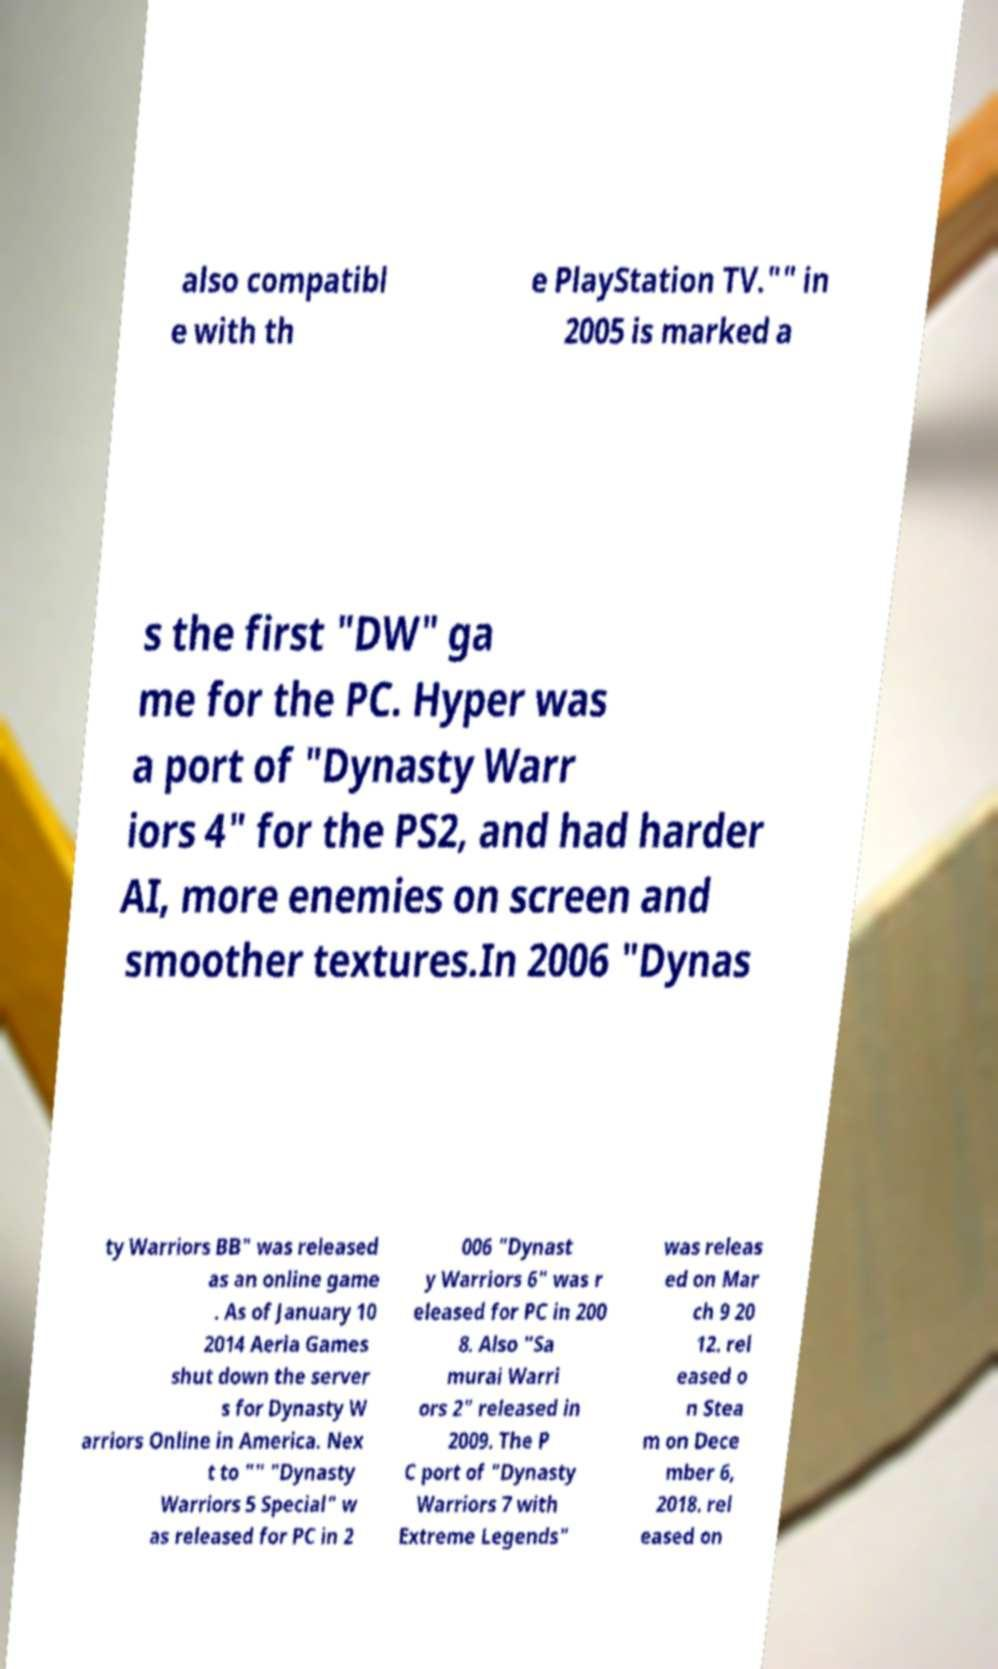Could you extract and type out the text from this image? also compatibl e with th e PlayStation TV."" in 2005 is marked a s the first "DW" ga me for the PC. Hyper was a port of "Dynasty Warr iors 4" for the PS2, and had harder AI, more enemies on screen and smoother textures.In 2006 "Dynas ty Warriors BB" was released as an online game . As of January 10 2014 Aeria Games shut down the server s for Dynasty W arriors Online in America. Nex t to "" "Dynasty Warriors 5 Special" w as released for PC in 2 006 "Dynast y Warriors 6" was r eleased for PC in 200 8. Also "Sa murai Warri ors 2" released in 2009. The P C port of "Dynasty Warriors 7 with Extreme Legends" was releas ed on Mar ch 9 20 12. rel eased o n Stea m on Dece mber 6, 2018. rel eased on 